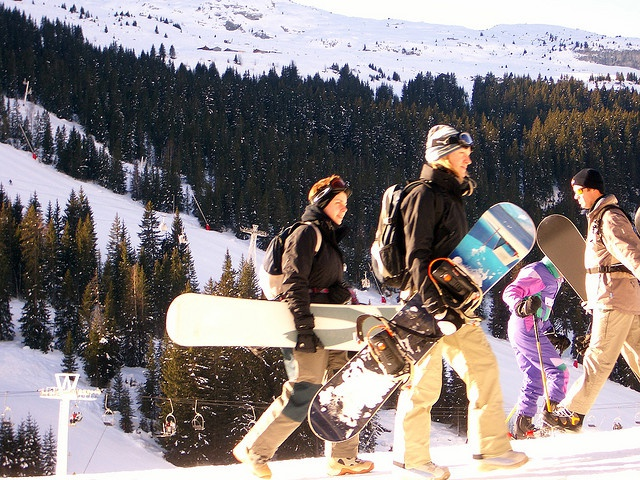Describe the objects in this image and their specific colors. I can see snowboard in lavender, ivory, gray, black, and darkgray tones, people in lavender, black, tan, and ivory tones, people in lavender, black, tan, and beige tones, people in lavender, ivory, and tan tones, and people in lavender, violet, and black tones in this image. 